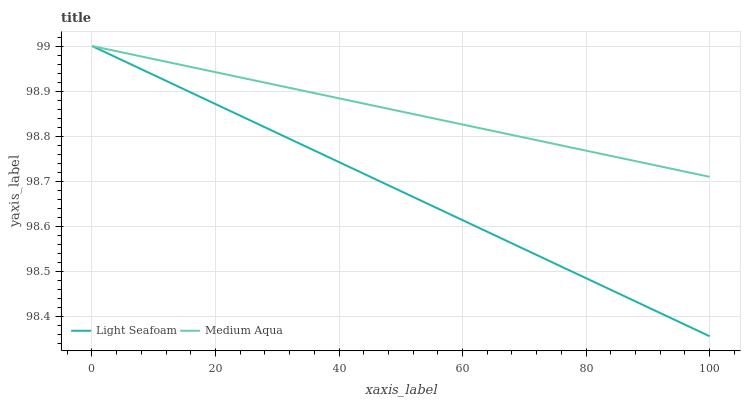Does Medium Aqua have the minimum area under the curve?
Answer yes or no. No. Is Medium Aqua the smoothest?
Answer yes or no. No. Does Medium Aqua have the lowest value?
Answer yes or no. No. 